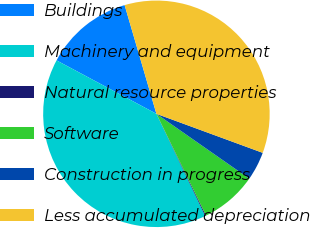Convert chart to OTSL. <chart><loc_0><loc_0><loc_500><loc_500><pie_chart><fcel>Buildings<fcel>Machinery and equipment<fcel>Natural resource properties<fcel>Software<fcel>Construction in progress<fcel>Less accumulated depreciation<nl><fcel>12.65%<fcel>39.91%<fcel>0.13%<fcel>8.08%<fcel>4.1%<fcel>35.13%<nl></chart> 